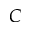<formula> <loc_0><loc_0><loc_500><loc_500>C</formula> 